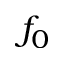<formula> <loc_0><loc_0><loc_500><loc_500>f _ { 0 }</formula> 